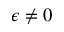Convert formula to latex. <formula><loc_0><loc_0><loc_500><loc_500>\epsilon \neq 0</formula> 